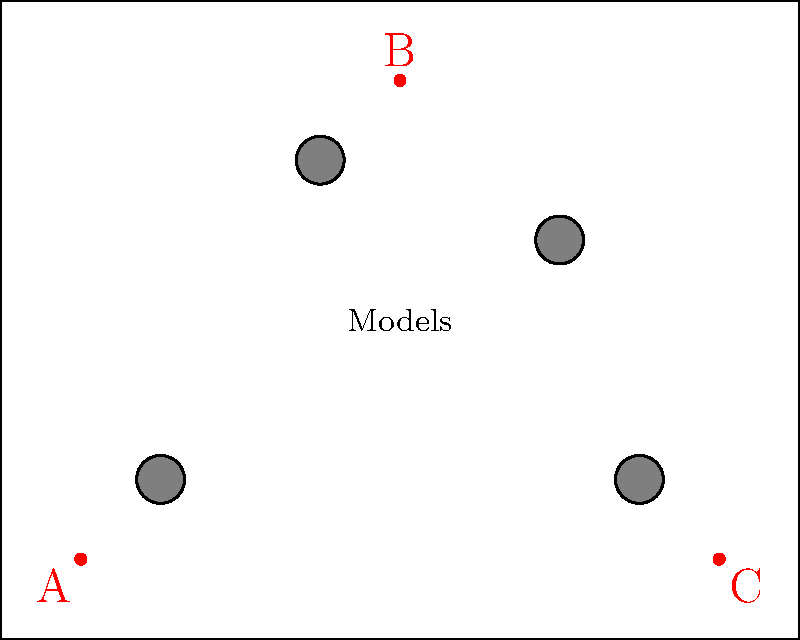In a high-profile fashion photoshoot, you need to determine the best camera placement for a group shot. The studio layout is represented as a 10x8 grid, with four models positioned as shown. Three potential camera positions (A, B, and C) are marked. Which camera position would capture all four models within the smallest viewing angle? To determine the camera position with the smallest viewing angle that captures all four models, we need to calculate the angle formed by the two most extreme models from each camera position:

1. For position A (1,1):
   - Extreme models: (2,2) and (8,2)
   - Angle = $\arctan(\frac{8-1}{2-1}) - \arctan(\frac{2-1}{2-1}) \approx 81.87°$

2. For position B (5,7):
   - Extreme models: (2,2) and (8,2)
   - Angle = $\arctan(\frac{2-7}{2-5}) - \arctan(\frac{2-7}{8-5}) \approx 69.44°$

3. For position C (9,1):
   - Extreme models: (2,2) and (7,5)
   - Angle = $\arctan(\frac{5-1}{7-9}) - \arctan(\frac{2-1}{2-9}) \approx 76.61°$

The smallest viewing angle is from position B at approximately 69.44°.
Answer: B 